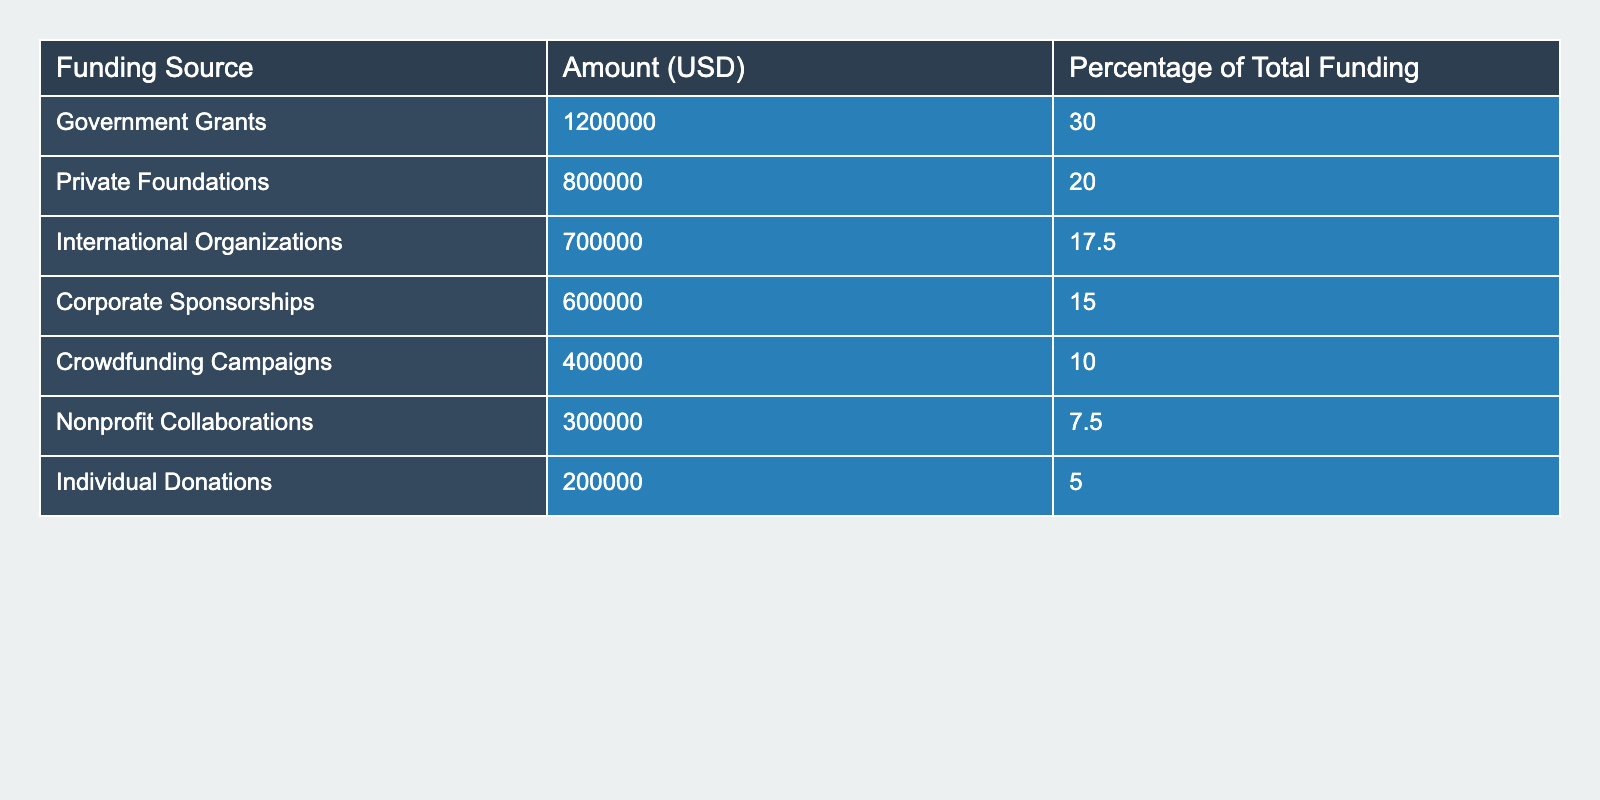What is the total amount of funding from Government Grants? The table shows that the amount of funding from Government Grants is listed as 1,200,000 USD.
Answer: 1,200,000 USD Which funding source contributed the least to marine conservation projects? The table indicates that Individual Donations contributed the least, with an amount of 200,000 USD.
Answer: Individual Donations What percentage of the total funding comes from Corporate Sponsorships? According to the table, Corporate Sponsorships account for 15% of the total funding.
Answer: 15% Which two sources combined contributed the largest percentage of total funding? Government Grants (30%) and Private Foundations (20%) combined for 50% of total funding.
Answer: Government Grants and Private Foundations What is the difference in funding between International Organizations and Crowdfunding Campaigns? The International Organizations received 700,000 USD and Crowdfunding Campaigns received 400,000 USD. The difference is 700,000 - 400,000 = 300,000 USD.
Answer: 300,000 USD What is the total funding amount from Nonprofit Collaborations and Individual Donations? Nonprofit Collaborations contributed 300,000 USD and Individual Donations contributed 200,000 USD. Adding these gives 300,000 + 200,000 = 500,000 USD.
Answer: 500,000 USD Is the funding from Private Foundations more than that from Corporate Sponsorships? The table shows Private Foundations received 800,000 USD and Corporate Sponsorships received 600,000 USD. So, 800,000 is indeed more than 600,000.
Answer: Yes Calculate the average funding amount from all sources. The total funding amount is 4,000,000 USD (sum of all sources). There are 8 sources, thus average funding is 4,000,000 / 8 = 500,000 USD.
Answer: 500,000 USD What percentage does the funding from Crowdfunding Campaigns represent when combined with funding from Individual Donations? Crowdfunding Campaigns are at 10% and Individual Donations are at 5%, together they represent 10% + 5% = 15% of total funding.
Answer: 15% Which funding source represents more than 20% of the total funding? The only source with more than 20% is Government Grants at 30%.
Answer: Government Grants 